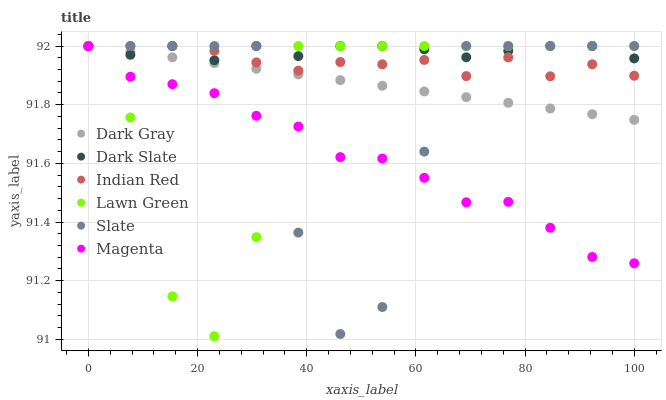Does Magenta have the minimum area under the curve?
Answer yes or no. Yes. Does Dark Slate have the maximum area under the curve?
Answer yes or no. Yes. Does Slate have the minimum area under the curve?
Answer yes or no. No. Does Slate have the maximum area under the curve?
Answer yes or no. No. Is Dark Gray the smoothest?
Answer yes or no. Yes. Is Slate the roughest?
Answer yes or no. Yes. Is Slate the smoothest?
Answer yes or no. No. Is Dark Gray the roughest?
Answer yes or no. No. Does Lawn Green have the lowest value?
Answer yes or no. Yes. Does Slate have the lowest value?
Answer yes or no. No. Does Indian Red have the highest value?
Answer yes or no. Yes. Does Magenta have the highest value?
Answer yes or no. No. Is Magenta less than Indian Red?
Answer yes or no. Yes. Is Indian Red greater than Magenta?
Answer yes or no. Yes. Does Slate intersect Magenta?
Answer yes or no. Yes. Is Slate less than Magenta?
Answer yes or no. No. Is Slate greater than Magenta?
Answer yes or no. No. Does Magenta intersect Indian Red?
Answer yes or no. No. 